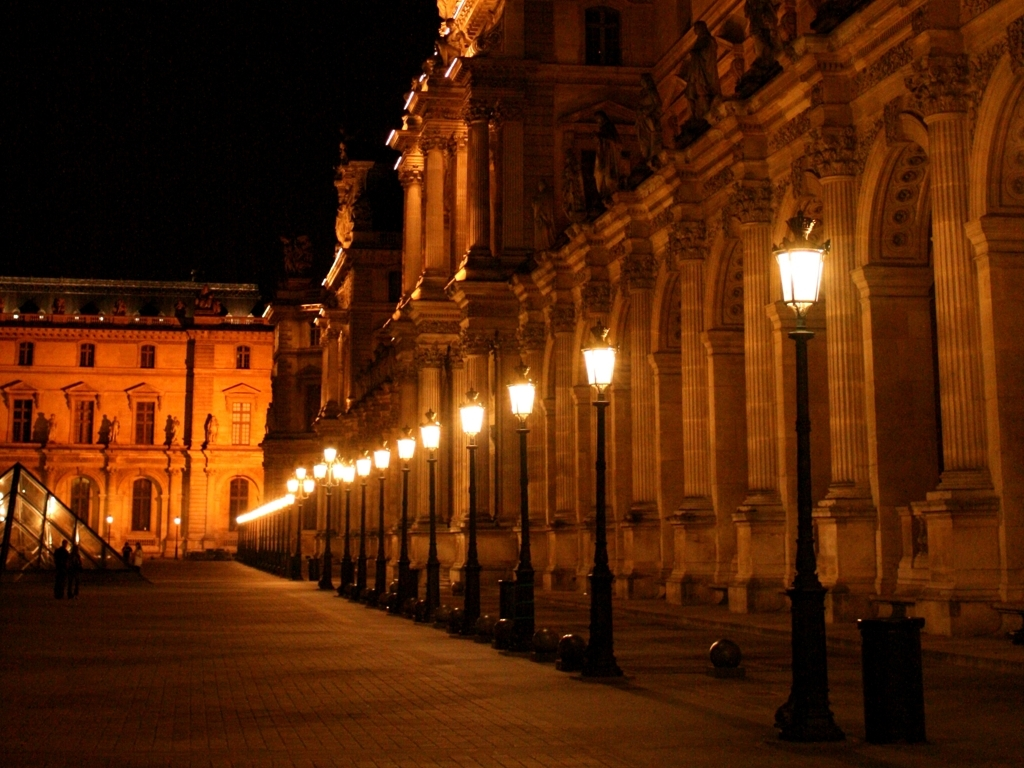What style of architecture is featured in this image? The architecture in the image features characteristics of the Beaux-Arts style, notable for its grandeur, classical details, and symmetry. 